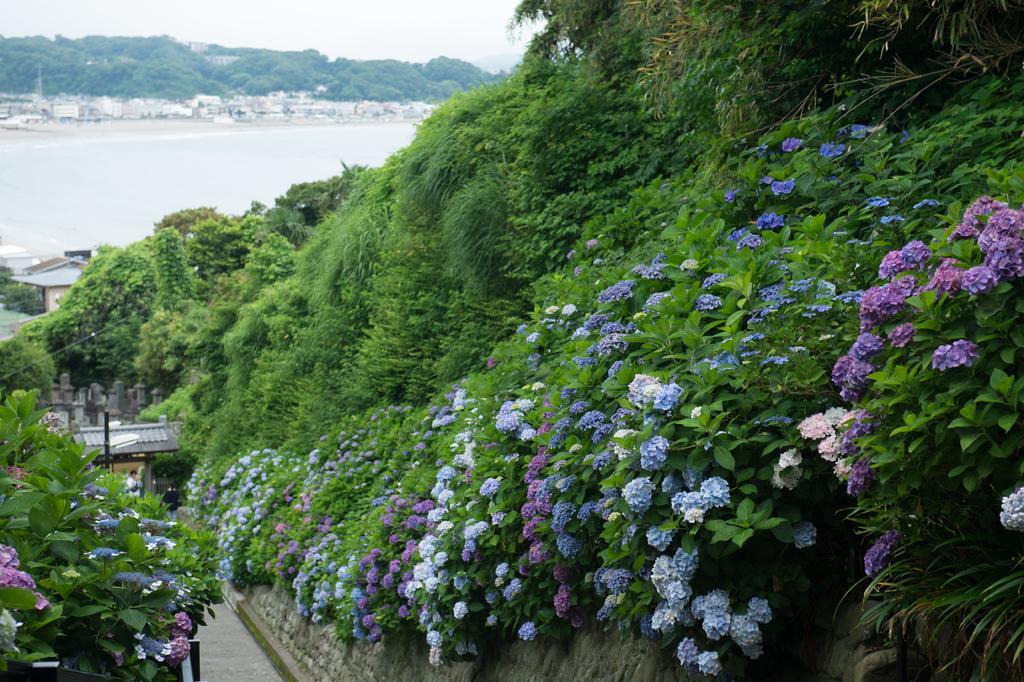Describe this image in one or two sentences. In this image there is a wall having few plants with flowers. Behind there are few trees. A person is standing on the floor. Left bottom there are few plants having flowers. Behind there are few trees and houses. Left side there is water. behind there are few buildings and trees are on the land. Top of the image there is sky. 